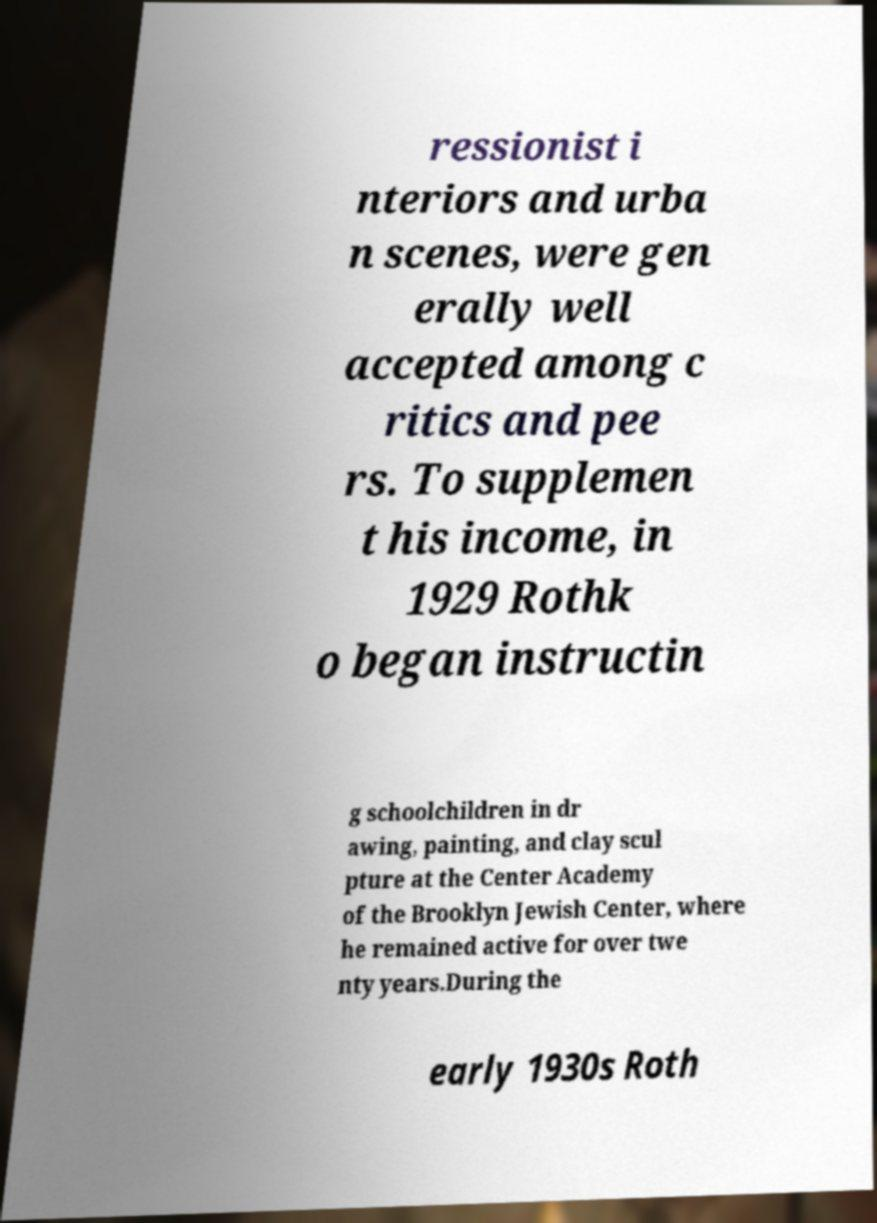I need the written content from this picture converted into text. Can you do that? ressionist i nteriors and urba n scenes, were gen erally well accepted among c ritics and pee rs. To supplemen t his income, in 1929 Rothk o began instructin g schoolchildren in dr awing, painting, and clay scul pture at the Center Academy of the Brooklyn Jewish Center, where he remained active for over twe nty years.During the early 1930s Roth 